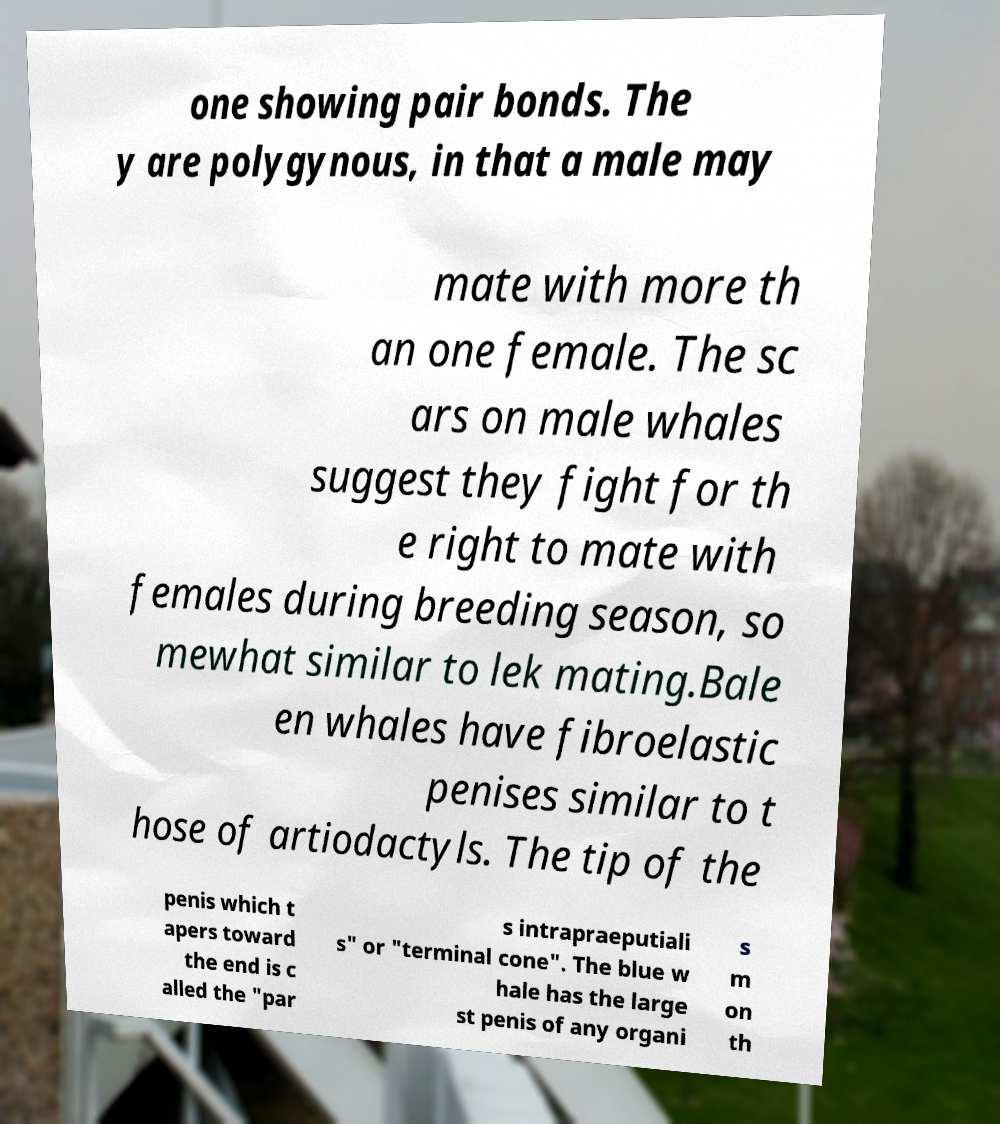I need the written content from this picture converted into text. Can you do that? one showing pair bonds. The y are polygynous, in that a male may mate with more th an one female. The sc ars on male whales suggest they fight for th e right to mate with females during breeding season, so mewhat similar to lek mating.Bale en whales have fibroelastic penises similar to t hose of artiodactyls. The tip of the penis which t apers toward the end is c alled the "par s intrapraeputiali s" or "terminal cone". The blue w hale has the large st penis of any organi s m on th 